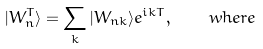Convert formula to latex. <formula><loc_0><loc_0><loc_500><loc_500>| W ^ { T } _ { n } \rangle = \sum _ { k } | W _ { n { k } } \rangle e ^ { i { k T } } , \quad w h e r e</formula> 